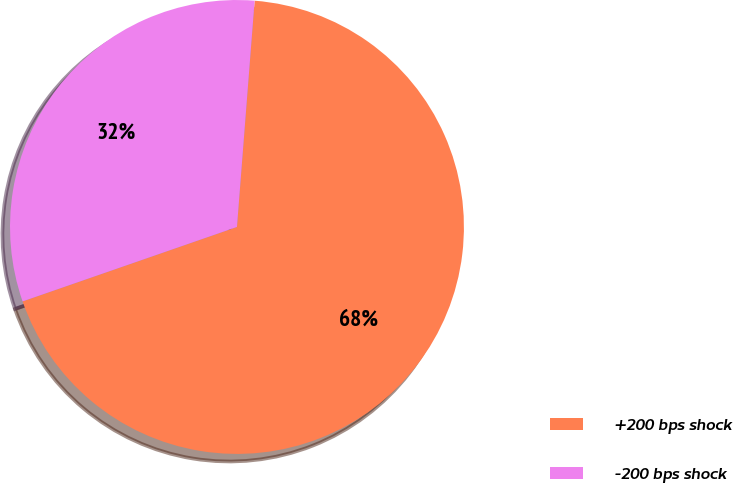<chart> <loc_0><loc_0><loc_500><loc_500><pie_chart><fcel>+200 bps shock<fcel>-200 bps shock<nl><fcel>68.44%<fcel>31.56%<nl></chart> 